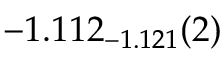<formula> <loc_0><loc_0><loc_500><loc_500>- 1 . 1 1 2 _ { - 1 . 1 2 1 } ( 2 )</formula> 